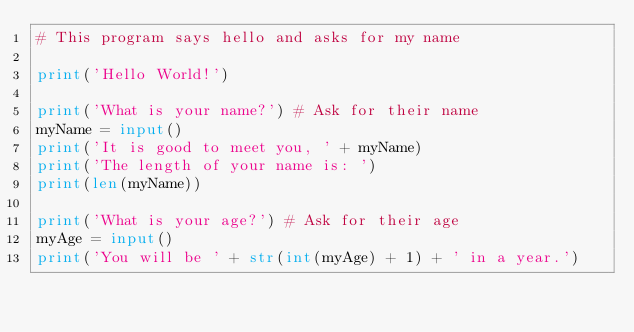Convert code to text. <code><loc_0><loc_0><loc_500><loc_500><_Python_># This program says hello and asks for my name

print('Hello World!')

print('What is your name?') # Ask for their name
myName = input()
print('It is good to meet you, ' + myName)
print('The length of your name is: ')
print(len(myName))

print('What is your age?') # Ask for their age
myAge = input()
print('You will be ' + str(int(myAge) + 1) + ' in a year.')
</code> 